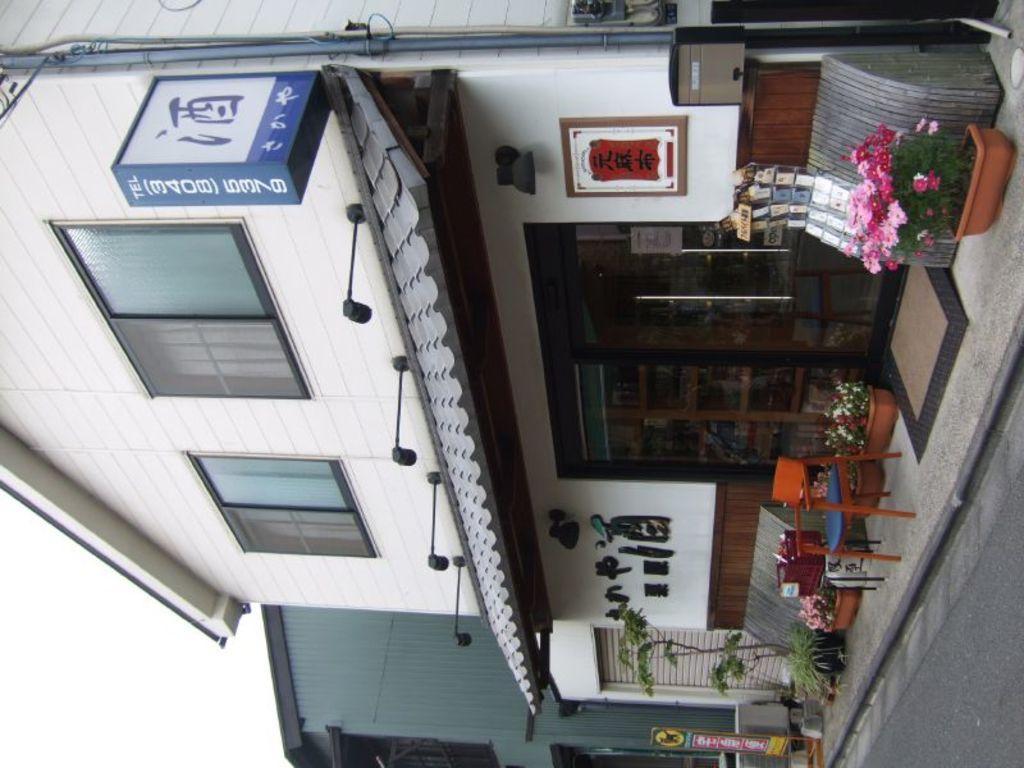Could you give a brief overview of what you see in this image? It is a horizontal image, where there is a house,below the house there is a store it has some flowers, a chair and some other photo frames outside the store,to the right side upwards there is also a board with store contact number,in the background there is a sky. 